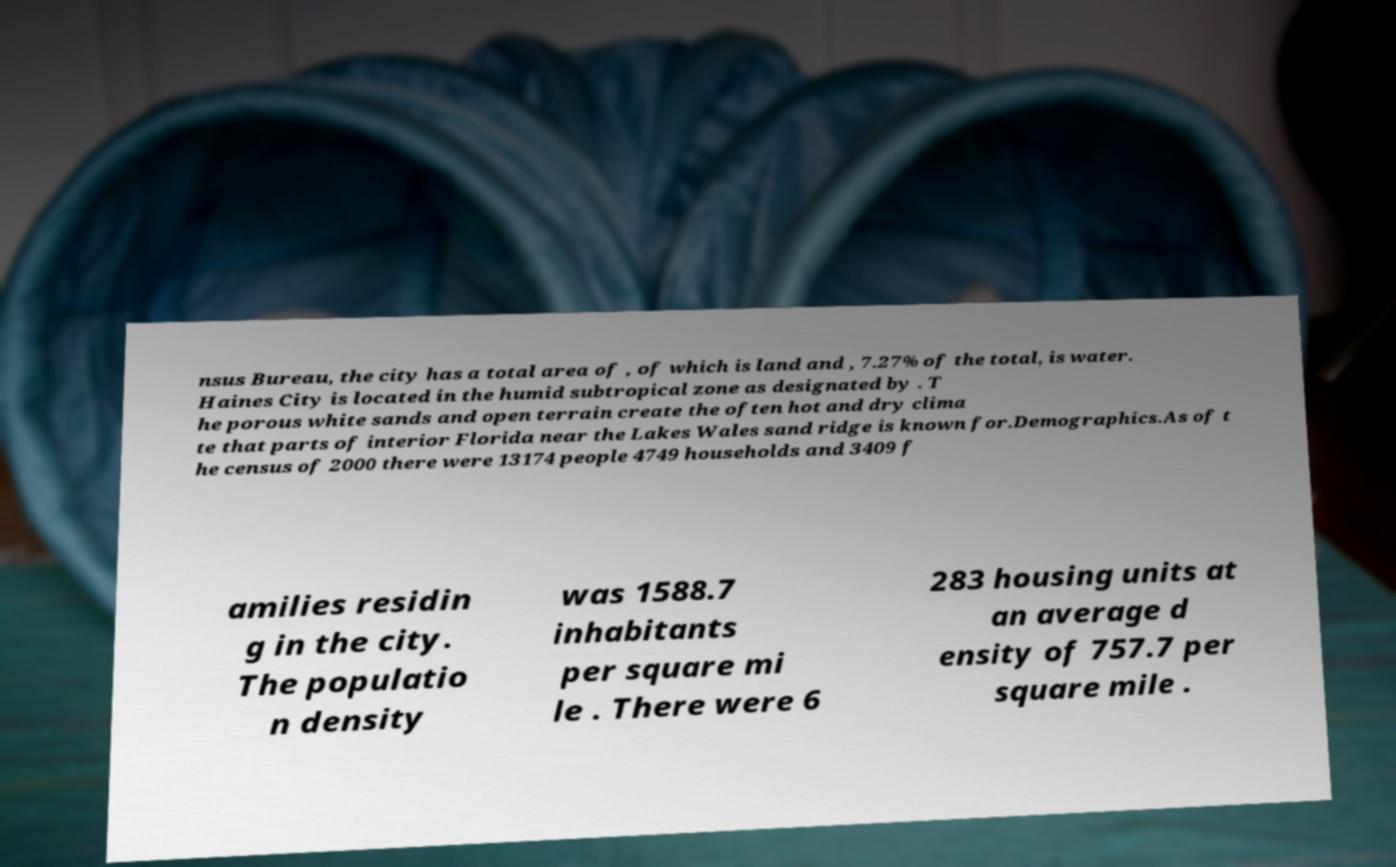Can you accurately transcribe the text from the provided image for me? nsus Bureau, the city has a total area of , of which is land and , 7.27% of the total, is water. Haines City is located in the humid subtropical zone as designated by . T he porous white sands and open terrain create the often hot and dry clima te that parts of interior Florida near the Lakes Wales sand ridge is known for.Demographics.As of t he census of 2000 there were 13174 people 4749 households and 3409 f amilies residin g in the city. The populatio n density was 1588.7 inhabitants per square mi le . There were 6 283 housing units at an average d ensity of 757.7 per square mile . 